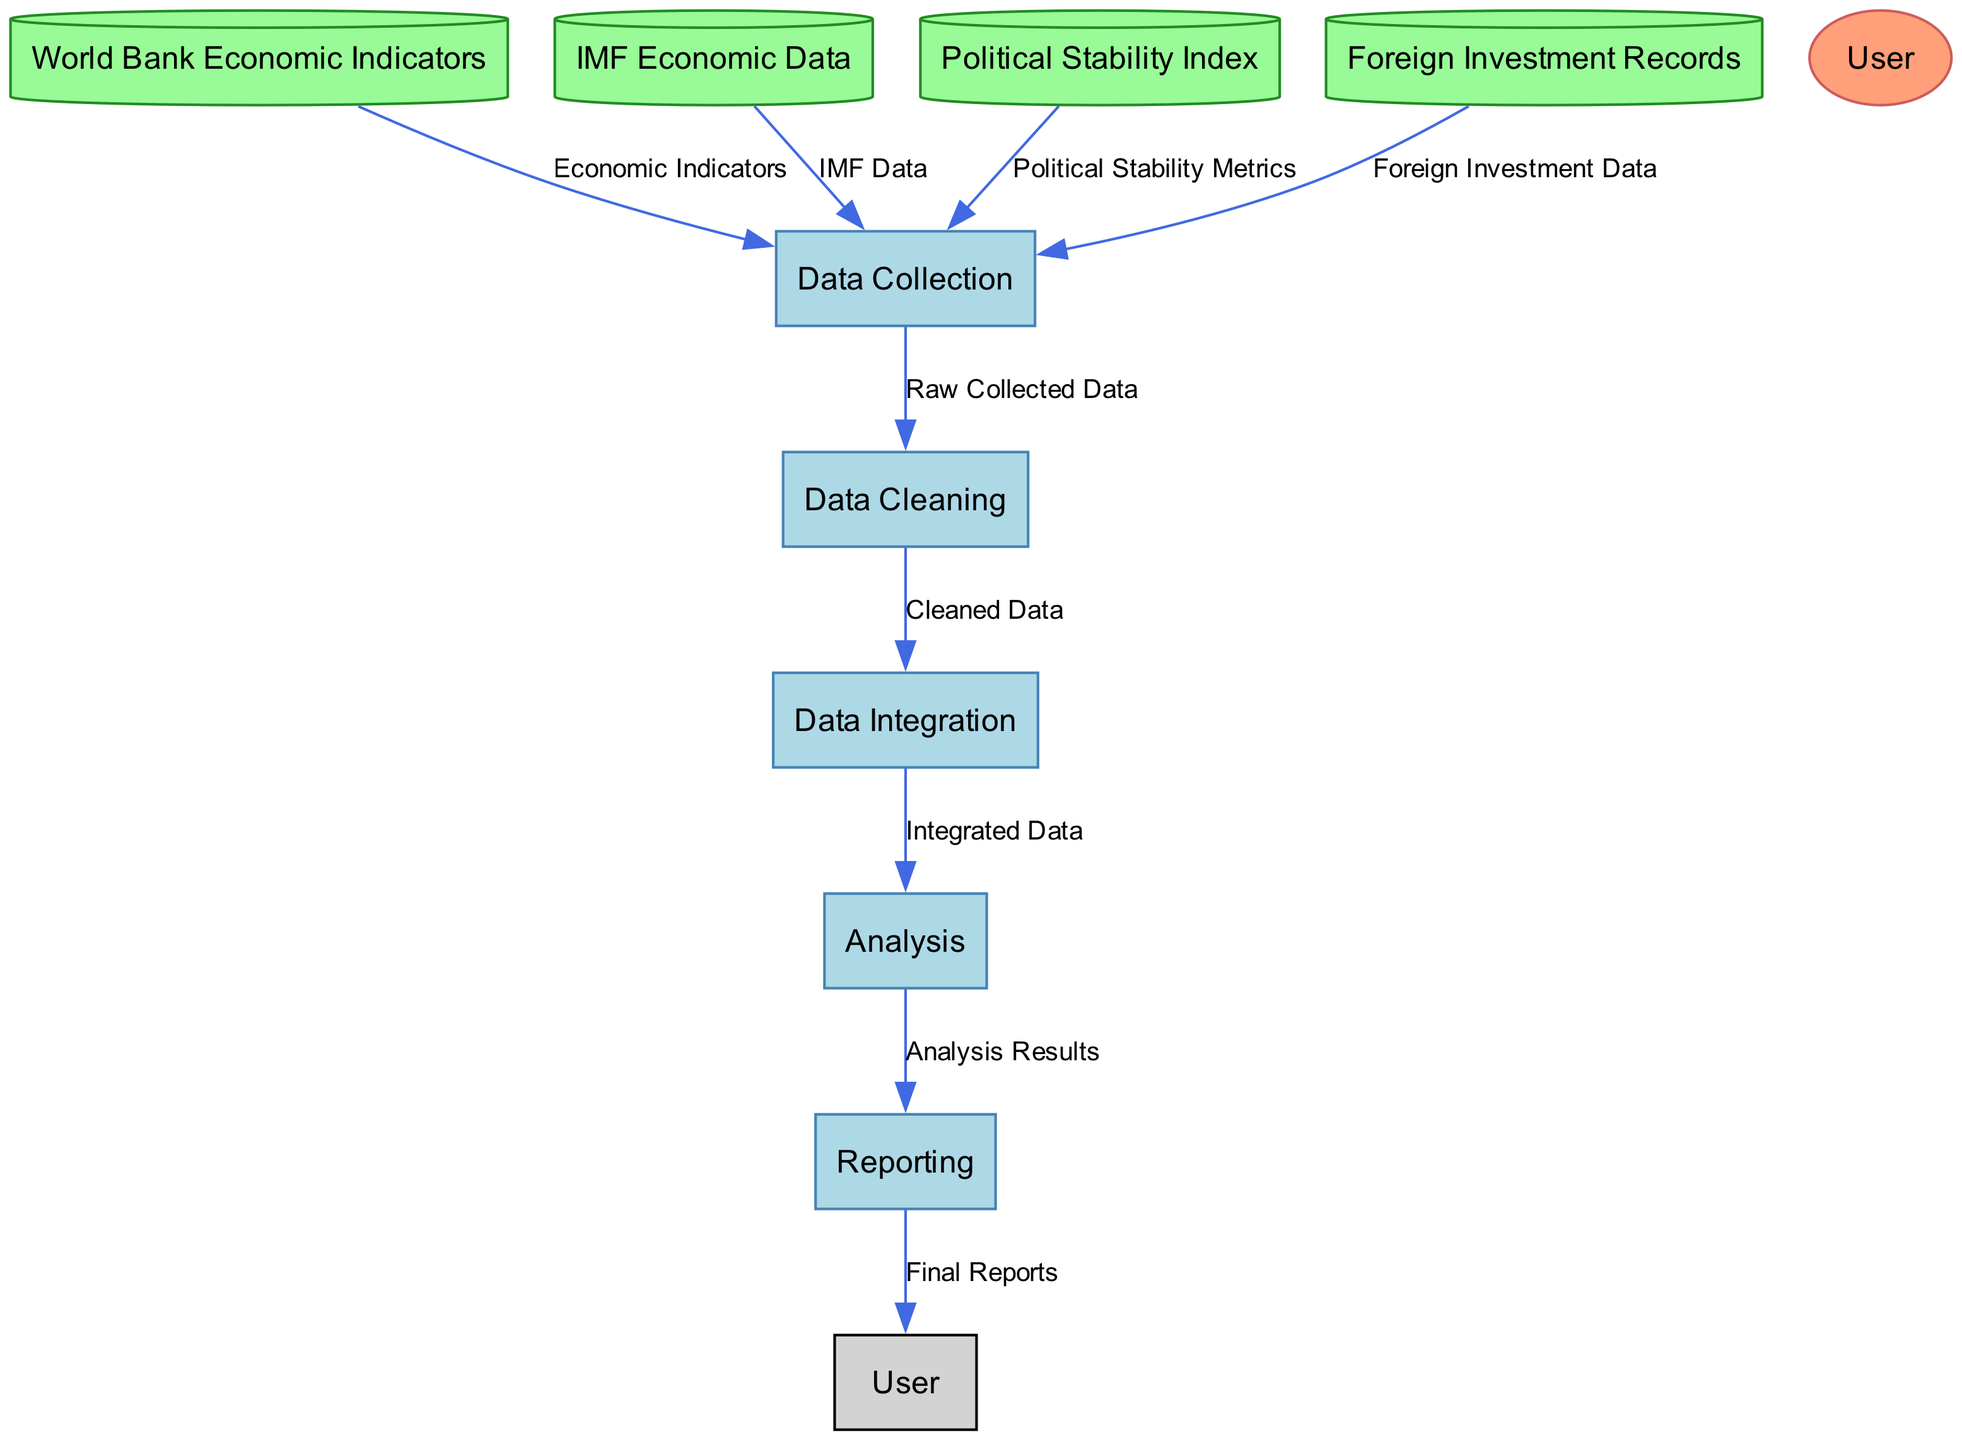What is the first process in the diagram? The first process is labeled as "P1", which corresponds to "Data Collection". This is indicated as the initiator of the data flow in the diagram.
Answer: Data Collection How many data stores are present in the diagram? By counting the nodes for data stores, four distinct data stores can be identified: World Bank Economic Indicators, IMF Economic Data, Political Stability Index, and Foreign Investment Records.
Answer: Four What is the relationship between "Data Cleaning" and "Data Integration"? The relationship is that "Data Cleaning" (P2) provides "Cleaned Data" (DF6) as input to "Data Integration" (P3). This shows a sequential process where cleaned data is necessary before integration.
Answer: Cleaned Data Which external entity is involved in this process? The external entity involved in this process is labeled as "User", indicating that an economist is conducting the research using the outputs of this diagram.
Answer: User What type of flow does "Integrated Data" represent? The flow "Integrated Data" (DF7) represents the output of "Data Integration" (P3) moving into the "Analysis" process (P4). This indicates that integrated data is the input for analysis.
Answer: Output What does the "Reporting" process generate? The "Reporting" process (P5) generates "Final Reports" (DF9) as its output, by compiling and presenting the findings of the analysis.
Answer: Final Reports What is the last process in this data flow? The last process in the data flow is "Reporting", which summarizes the findings from the analysis into final reports, marking the completion of the flow.
Answer: Reporting Which process directly follows "Data Integration"? The process that directly follows "Data Integration" (P3) is "Analysis" (P4), which takes the integrated data as input for further examination.
Answer: Analysis What type of data does "Data Collection" receive from "Political Stability Index"? "Data Collection" receives "Political Stability Metrics" from the "Political Stability Index" data store, which is one of the sources for the collected data.
Answer: Political Stability Metrics 